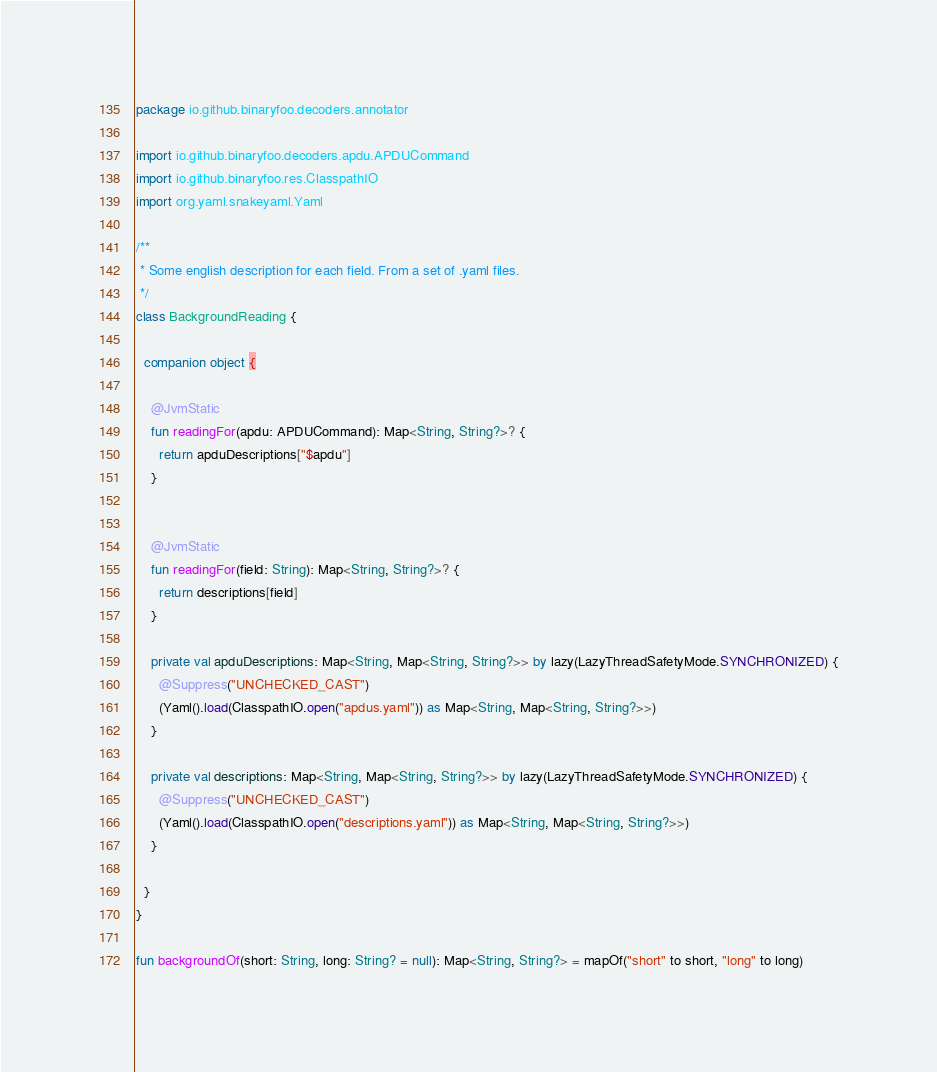Convert code to text. <code><loc_0><loc_0><loc_500><loc_500><_Kotlin_>package io.github.binaryfoo.decoders.annotator

import io.github.binaryfoo.decoders.apdu.APDUCommand
import io.github.binaryfoo.res.ClasspathIO
import org.yaml.snakeyaml.Yaml

/**
 * Some english description for each field. From a set of .yaml files.
 */
class BackgroundReading {

  companion object {

    @JvmStatic
    fun readingFor(apdu: APDUCommand): Map<String, String?>? {
      return apduDescriptions["$apdu"]
    }


    @JvmStatic
    fun readingFor(field: String): Map<String, String?>? {
      return descriptions[field]
    }

    private val apduDescriptions: Map<String, Map<String, String?>> by lazy(LazyThreadSafetyMode.SYNCHRONIZED) {
      @Suppress("UNCHECKED_CAST")
      (Yaml().load(ClasspathIO.open("apdus.yaml")) as Map<String, Map<String, String?>>)
    }

    private val descriptions: Map<String, Map<String, String?>> by lazy(LazyThreadSafetyMode.SYNCHRONIZED) {
      @Suppress("UNCHECKED_CAST")
      (Yaml().load(ClasspathIO.open("descriptions.yaml")) as Map<String, Map<String, String?>>)
    }

  }
}

fun backgroundOf(short: String, long: String? = null): Map<String, String?> = mapOf("short" to short, "long" to long)
</code> 